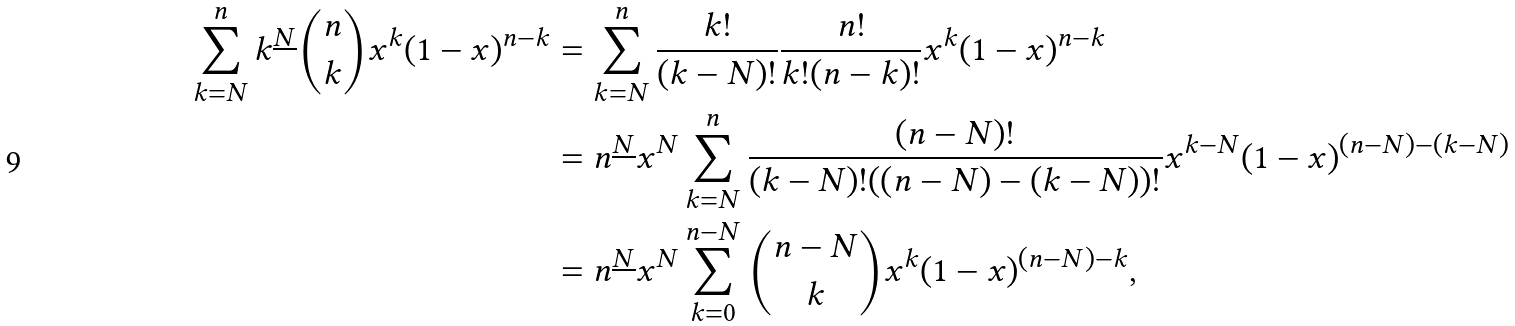<formula> <loc_0><loc_0><loc_500><loc_500>\sum _ { k = N } ^ { n } k ^ { \underline { N } } \binom { n } { k } x ^ { k } ( 1 - x ) ^ { n - k } & = \sum _ { k = N } ^ { n } \frac { k ! } { ( k - N ) ! } \frac { n ! } { k ! ( n - k ) ! } x ^ { k } ( 1 - x ) ^ { n - k } \\ & = n ^ { \underline { N } } x ^ { N } \sum _ { k = N } ^ { n } \frac { ( n - N ) ! } { ( k - N ) ! ( ( n - N ) - ( k - N ) ) ! } x ^ { k - N } ( 1 - x ) ^ { ( n - N ) - ( k - N ) } \\ & = n ^ { \underline { N } } x ^ { N } \sum _ { k = 0 } ^ { n - N } \binom { n - N } { k } x ^ { k } ( 1 - x ) ^ { ( n - N ) - k } ,</formula> 